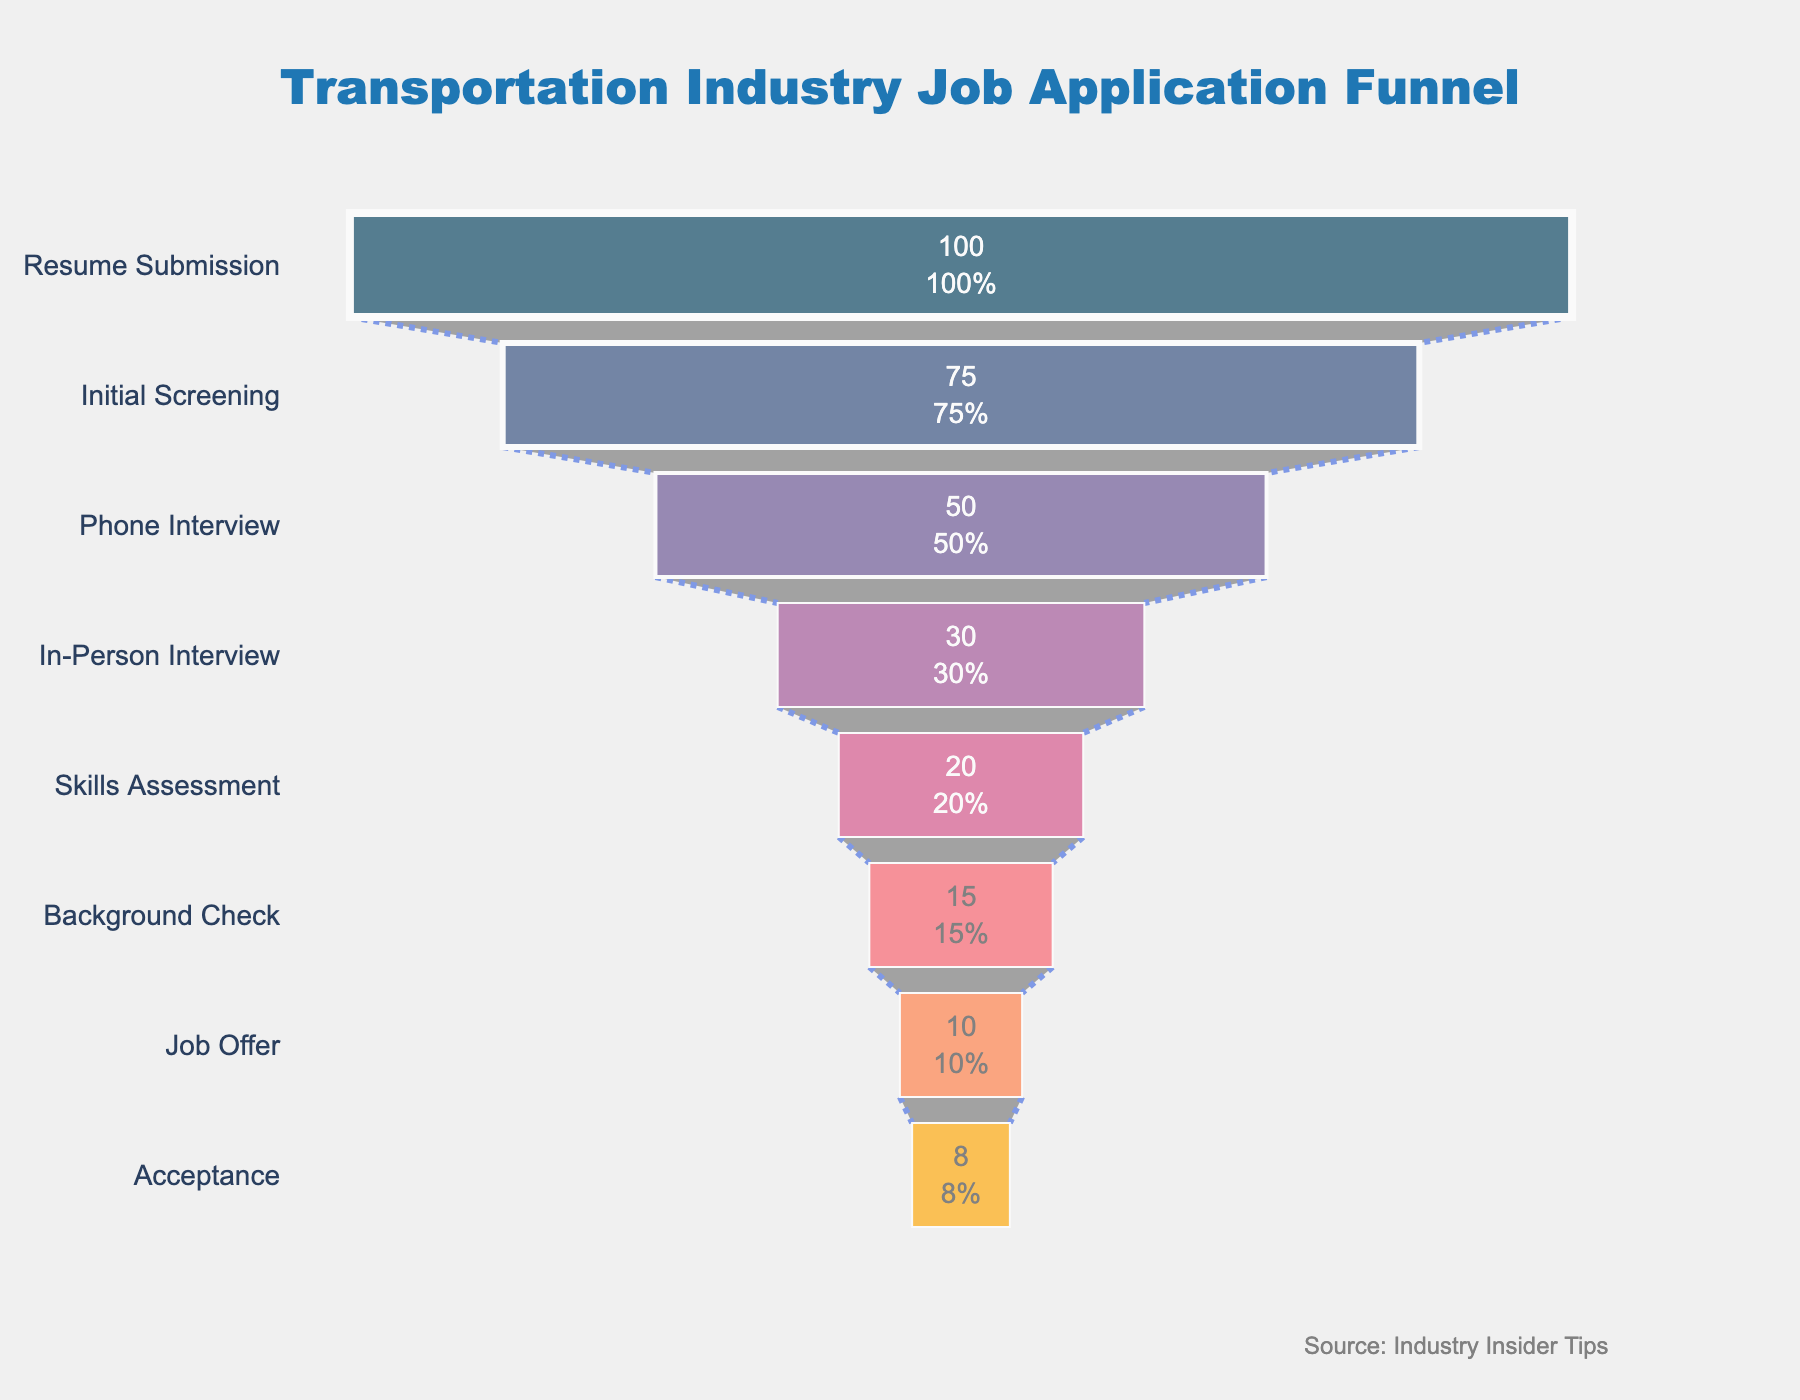what is the title of the figure? The title is usually located at the top of the chart and provides a summary of what the chart represents. In this case, it says "Transportation Industry Job Application Funnel".
Answer: Transportation Industry Job Application Funnel What percentage of applicants move from Initial Screening to Phone Interview? We can see in the funnel chart that 75 applicants start at the Initial Screening stage and 50 applicants make it to the Phone Interview stage. The percentage can be calculated as (50/75) * 100%.
Answer: 66.67% Which stage has the largest drop in applicant numbers? By analyzing the differences in applicant numbers between each stage, we identify that the largest drop occurs from Resume Submission (100 applicants) to Initial Screening (75 applicants), representing a drop of 25 applicants.
Answer: Resume Submission to Initial Screening How many stages are there in the job application process? The stages are listed along the y-axis of the funnel chart. Counting each unique stage name provides the total number of stages.
Answer: 8 What is the total percentage of applicants that move from Skills Assessment to Background Check? The Skills Assessment stage starts with 20 applicants and the Background Check stage has 15 applicants. The percentage is (15/20) * 100%.
Answer: 75% Compare the applicant drop-off between the In-Person Interview and Skills Assessment stages versus the Background Check and Job Offer stages. From In-Person Interview (30 applicants) to Skills Assessment (20 applicants), there is a drop-off of 10 applicants. From Background Check (15 applicants) to Job Offer (10 applicants), there is a drop-off of 5 applicants. Therefore, the drop between In-Person Interview and Skills Assessment is larger.
Answer: In-Person Interview to Skills Assessment What is the employment acceptance rate based on the total applicants who received a Job Offer? Out of the applicants who received a Job Offer (10), the number of those who accepted the offer can be compared, which is 8. The rate is calculated as (8/10) * 100%.
Answer: 80% Describe the color trend in the funnel chart. The colors of the stages transition smoothly from dark to light shades, starting from dark blue for the Resume Submission stage to a lighter shade of orange for the Acceptance stage.
Answer: Dark to light What additional annotation is provided in the figure? In the bottom right corner of the figure, there is a small annotation with the text "Source: Industry Insider Tips", indicating the data source.
Answer: Source: Industry Insider Tips 